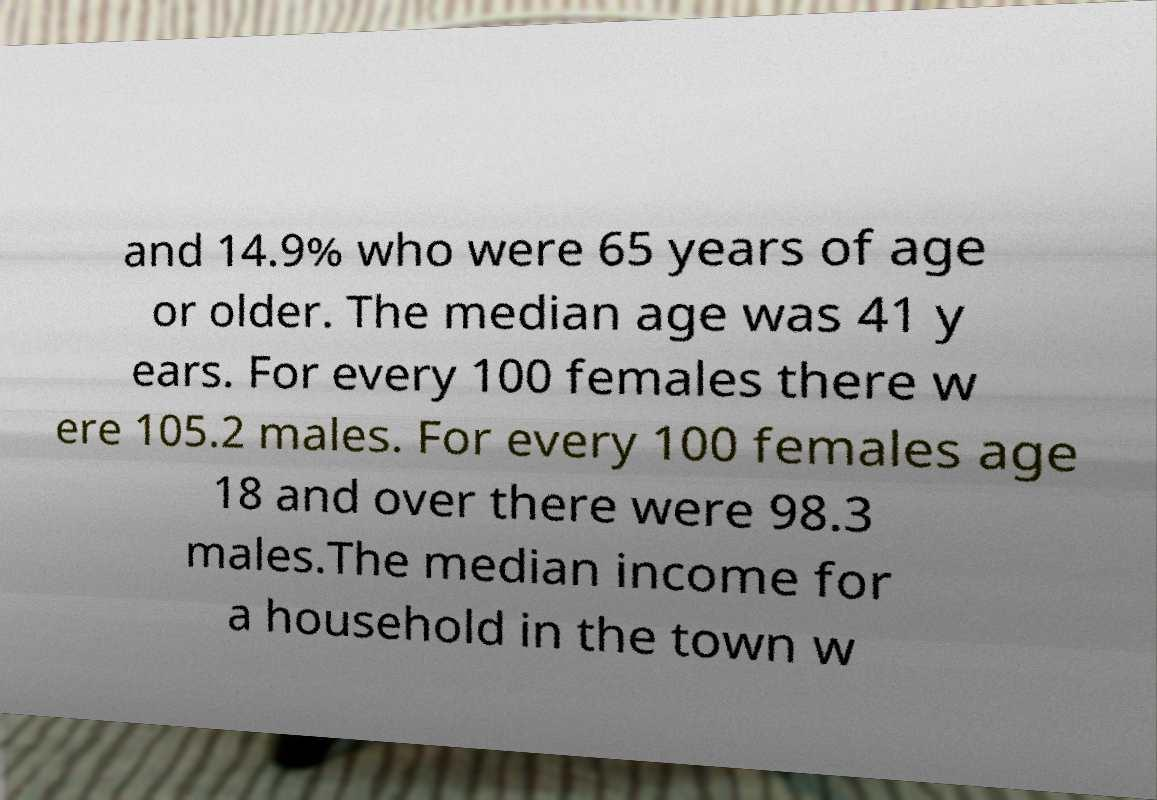For documentation purposes, I need the text within this image transcribed. Could you provide that? and 14.9% who were 65 years of age or older. The median age was 41 y ears. For every 100 females there w ere 105.2 males. For every 100 females age 18 and over there were 98.3 males.The median income for a household in the town w 